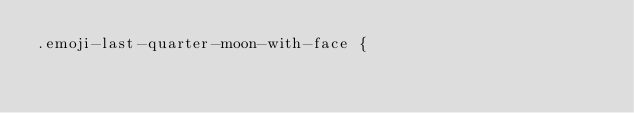<code> <loc_0><loc_0><loc_500><loc_500><_CSS_>.emoji-last-quarter-moon-with-face {</code> 